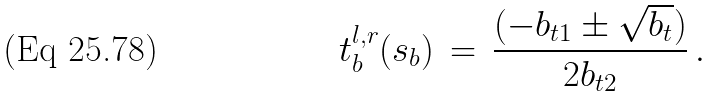<formula> <loc_0><loc_0><loc_500><loc_500>t _ { b } ^ { l , r } ( s _ { b } ) \, = \, \frac { ( - b _ { t 1 } \pm \sqrt { b _ { t } } ) } { 2 b _ { t 2 } } \, .</formula> 